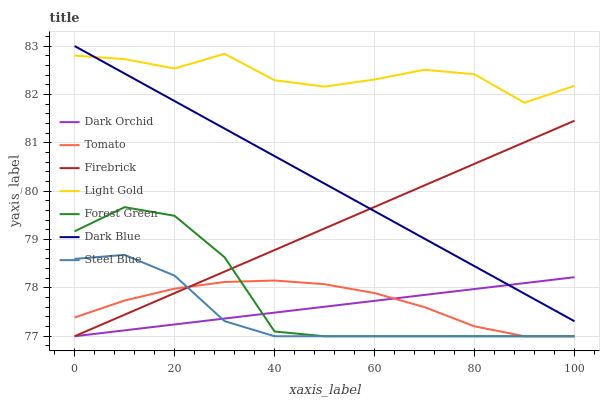Does Firebrick have the minimum area under the curve?
Answer yes or no. No. Does Firebrick have the maximum area under the curve?
Answer yes or no. No. Is Firebrick the smoothest?
Answer yes or no. No. Is Firebrick the roughest?
Answer yes or no. No. Does Dark Blue have the lowest value?
Answer yes or no. No. Does Firebrick have the highest value?
Answer yes or no. No. Is Tomato less than Light Gold?
Answer yes or no. Yes. Is Light Gold greater than Forest Green?
Answer yes or no. Yes. Does Tomato intersect Light Gold?
Answer yes or no. No. 